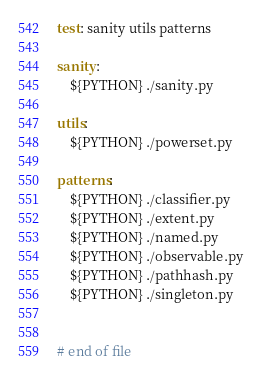<code> <loc_0><loc_0><loc_500><loc_500><_ObjectiveC_>
test: sanity utils patterns

sanity:
	${PYTHON} ./sanity.py

utils:
	${PYTHON} ./powerset.py

patterns:
	${PYTHON} ./classifier.py
	${PYTHON} ./extent.py
	${PYTHON} ./named.py
	${PYTHON} ./observable.py
	${PYTHON} ./pathhash.py
	${PYTHON} ./singleton.py


# end of file
</code> 